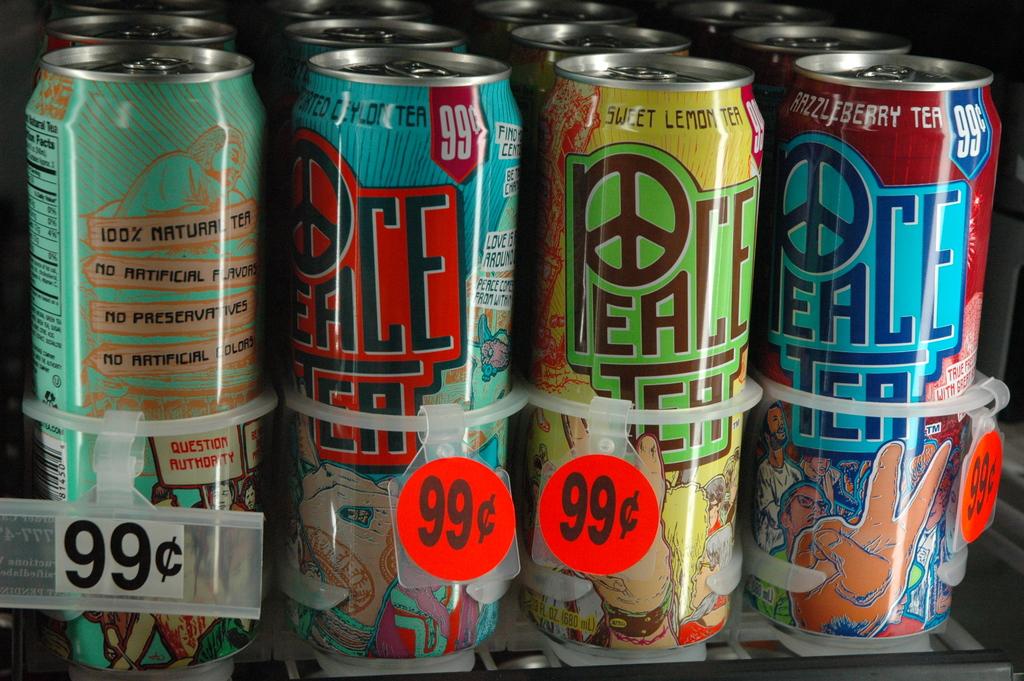What is the brand name of the drink?
Your answer should be compact. Peace tea. How much do the drinks cost?
Make the answer very short. 99 cents. 